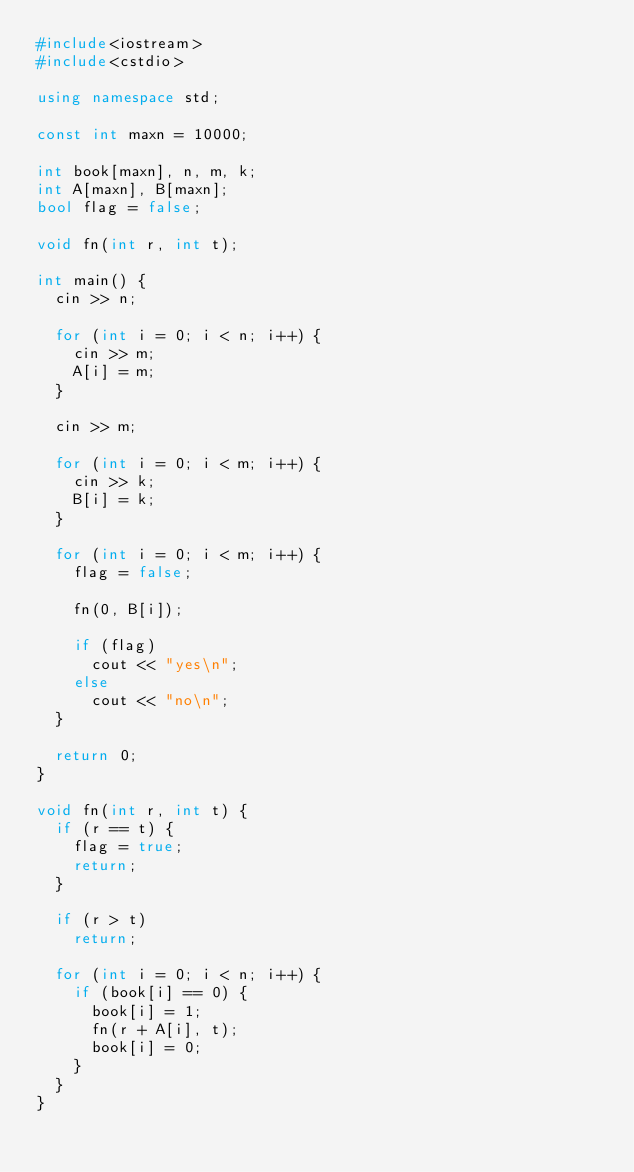<code> <loc_0><loc_0><loc_500><loc_500><_C++_>#include<iostream>
#include<cstdio>

using namespace std;

const int maxn = 10000;

int book[maxn], n, m, k;
int A[maxn], B[maxn];
bool flag = false;

void fn(int r, int t);

int main() {
  cin >> n;

  for (int i = 0; i < n; i++) {
    cin >> m;
    A[i] = m;
  }

  cin >> m;

  for (int i = 0; i < m; i++) {
    cin >> k;  
    B[i] = k;
  }

  for (int i = 0; i < m; i++) {
    flag = false;
    
    fn(0, B[i]);

    if (flag)
      cout << "yes\n";
    else
      cout << "no\n";
  }

  return 0;
}

void fn(int r, int t) {
  if (r == t) {
    flag = true;
    return;
  }

  if (r > t)
    return;

  for (int i = 0; i < n; i++) {
    if (book[i] == 0) {
      book[i] = 1;
      fn(r + A[i], t);
      book[i] = 0;
    }
  }
}</code> 